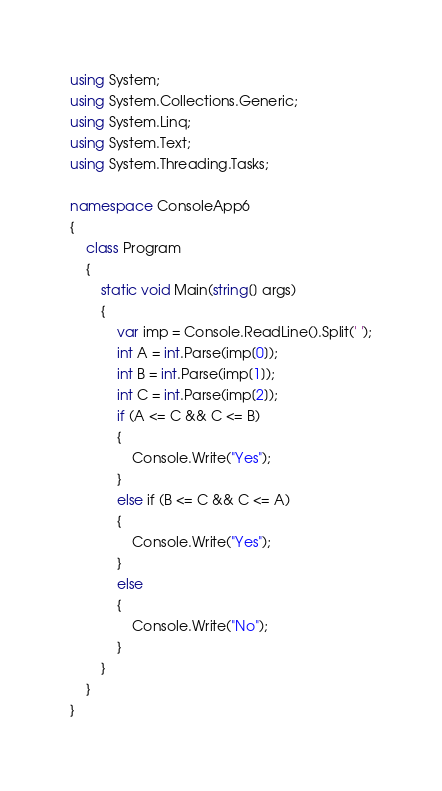Convert code to text. <code><loc_0><loc_0><loc_500><loc_500><_C#_>using System;
using System.Collections.Generic;
using System.Linq;
using System.Text;
using System.Threading.Tasks;

namespace ConsoleApp6
{
    class Program
    {
        static void Main(string[] args)
        {
            var imp = Console.ReadLine().Split(' ');
            int A = int.Parse(imp[0]);
            int B = int.Parse(imp[1]);
            int C = int.Parse(imp[2]);
            if (A <= C && C <= B)
            {
                Console.Write("Yes");
            }
            else if (B <= C && C <= A)
            {
                Console.Write("Yes");
            }
            else
            {
                Console.Write("No");
            }
        }
    }
}
</code> 